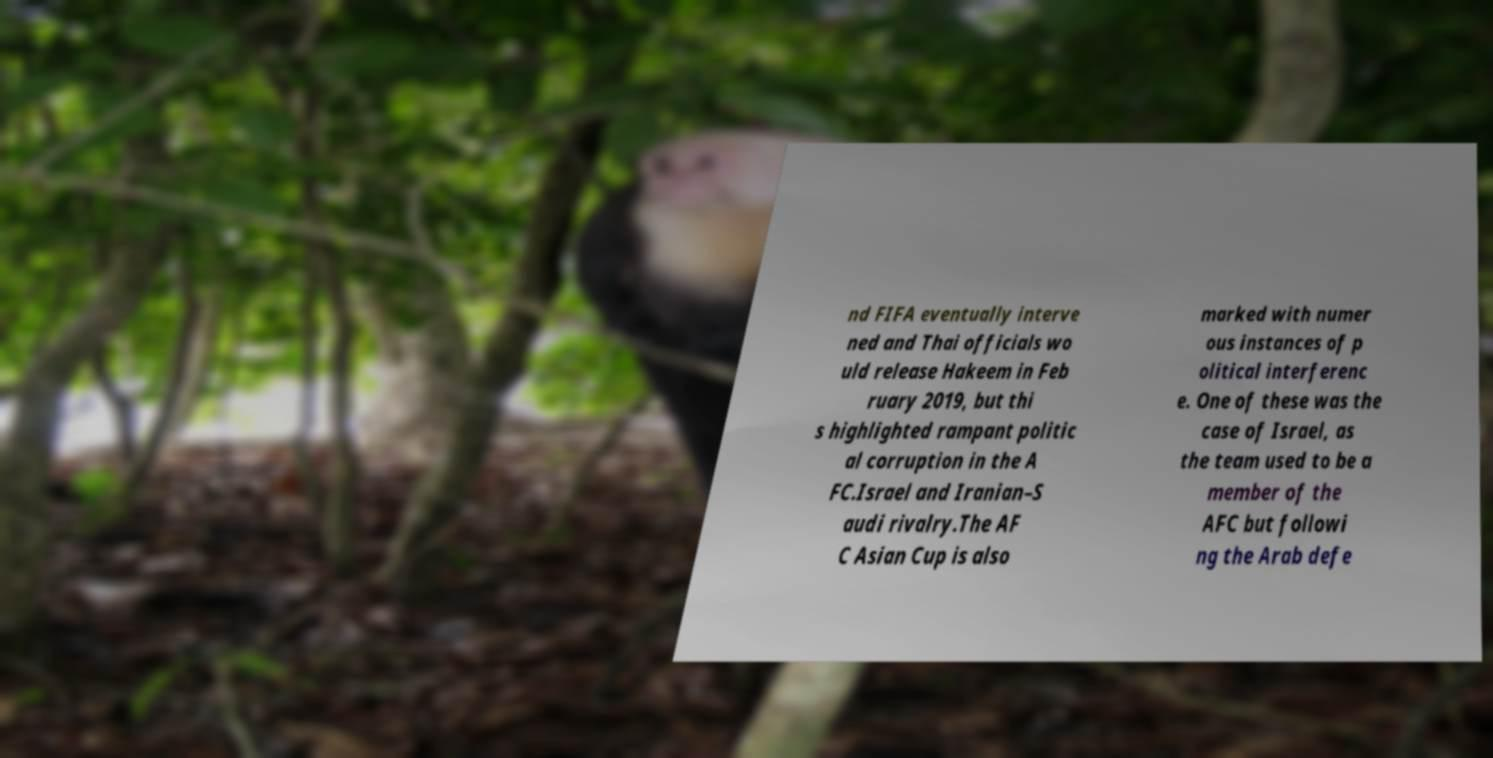Can you accurately transcribe the text from the provided image for me? nd FIFA eventually interve ned and Thai officials wo uld release Hakeem in Feb ruary 2019, but thi s highlighted rampant politic al corruption in the A FC.Israel and Iranian–S audi rivalry.The AF C Asian Cup is also marked with numer ous instances of p olitical interferenc e. One of these was the case of Israel, as the team used to be a member of the AFC but followi ng the Arab defe 